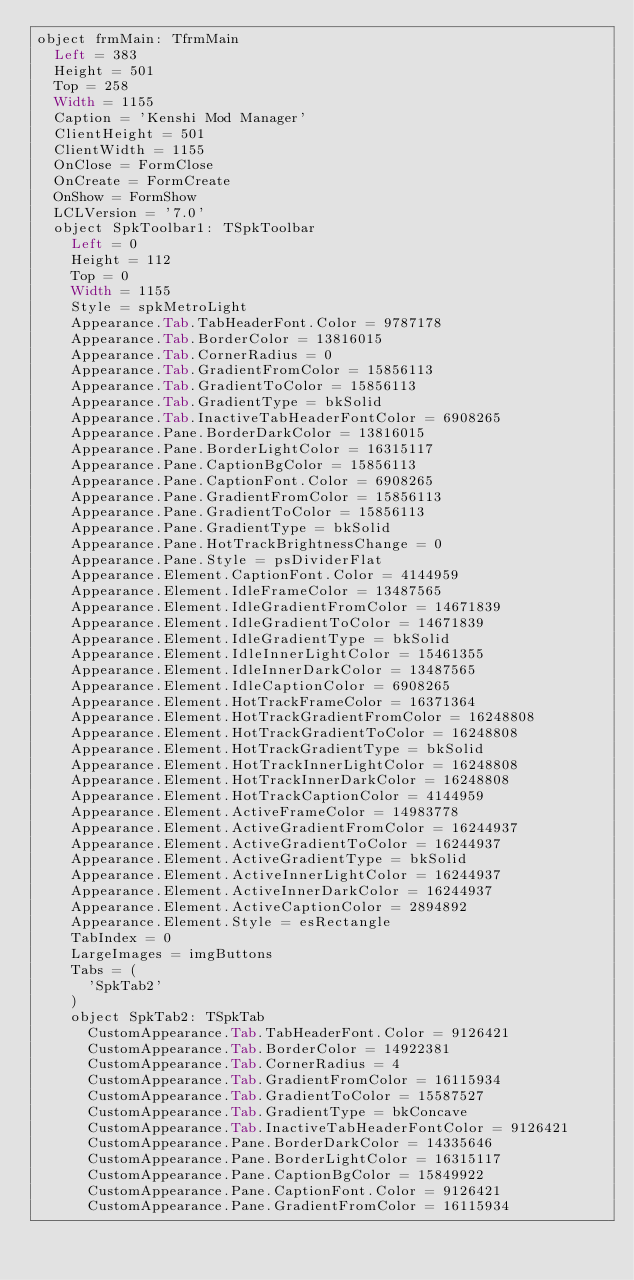<code> <loc_0><loc_0><loc_500><loc_500><_VisualBasic_>object frmMain: TfrmMain
  Left = 383
  Height = 501
  Top = 258
  Width = 1155
  Caption = 'Kenshi Mod Manager'
  ClientHeight = 501
  ClientWidth = 1155
  OnClose = FormClose
  OnCreate = FormCreate
  OnShow = FormShow
  LCLVersion = '7.0'
  object SpkToolbar1: TSpkToolbar
    Left = 0
    Height = 112
    Top = 0
    Width = 1155
    Style = spkMetroLight
    Appearance.Tab.TabHeaderFont.Color = 9787178
    Appearance.Tab.BorderColor = 13816015
    Appearance.Tab.CornerRadius = 0
    Appearance.Tab.GradientFromColor = 15856113
    Appearance.Tab.GradientToColor = 15856113
    Appearance.Tab.GradientType = bkSolid
    Appearance.Tab.InactiveTabHeaderFontColor = 6908265
    Appearance.Pane.BorderDarkColor = 13816015
    Appearance.Pane.BorderLightColor = 16315117
    Appearance.Pane.CaptionBgColor = 15856113
    Appearance.Pane.CaptionFont.Color = 6908265
    Appearance.Pane.GradientFromColor = 15856113
    Appearance.Pane.GradientToColor = 15856113
    Appearance.Pane.GradientType = bkSolid
    Appearance.Pane.HotTrackBrightnessChange = 0
    Appearance.Pane.Style = psDividerFlat
    Appearance.Element.CaptionFont.Color = 4144959
    Appearance.Element.IdleFrameColor = 13487565
    Appearance.Element.IdleGradientFromColor = 14671839
    Appearance.Element.IdleGradientToColor = 14671839
    Appearance.Element.IdleGradientType = bkSolid
    Appearance.Element.IdleInnerLightColor = 15461355
    Appearance.Element.IdleInnerDarkColor = 13487565
    Appearance.Element.IdleCaptionColor = 6908265
    Appearance.Element.HotTrackFrameColor = 16371364
    Appearance.Element.HotTrackGradientFromColor = 16248808
    Appearance.Element.HotTrackGradientToColor = 16248808
    Appearance.Element.HotTrackGradientType = bkSolid
    Appearance.Element.HotTrackInnerLightColor = 16248808
    Appearance.Element.HotTrackInnerDarkColor = 16248808
    Appearance.Element.HotTrackCaptionColor = 4144959
    Appearance.Element.ActiveFrameColor = 14983778
    Appearance.Element.ActiveGradientFromColor = 16244937
    Appearance.Element.ActiveGradientToColor = 16244937
    Appearance.Element.ActiveGradientType = bkSolid
    Appearance.Element.ActiveInnerLightColor = 16244937
    Appearance.Element.ActiveInnerDarkColor = 16244937
    Appearance.Element.ActiveCaptionColor = 2894892
    Appearance.Element.Style = esRectangle
    TabIndex = 0
    LargeImages = imgButtons
    Tabs = (
      'SpkTab2'
    )
    object SpkTab2: TSpkTab
      CustomAppearance.Tab.TabHeaderFont.Color = 9126421
      CustomAppearance.Tab.BorderColor = 14922381
      CustomAppearance.Tab.CornerRadius = 4
      CustomAppearance.Tab.GradientFromColor = 16115934
      CustomAppearance.Tab.GradientToColor = 15587527
      CustomAppearance.Tab.GradientType = bkConcave
      CustomAppearance.Tab.InactiveTabHeaderFontColor = 9126421
      CustomAppearance.Pane.BorderDarkColor = 14335646
      CustomAppearance.Pane.BorderLightColor = 16315117
      CustomAppearance.Pane.CaptionBgColor = 15849922
      CustomAppearance.Pane.CaptionFont.Color = 9126421
      CustomAppearance.Pane.GradientFromColor = 16115934</code> 